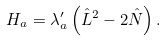<formula> <loc_0><loc_0><loc_500><loc_500>H _ { a } = \lambda _ { a } ^ { \prime } \left ( { \hat { L } ^ { 2 } - 2 \hat { N } } \right ) .</formula> 